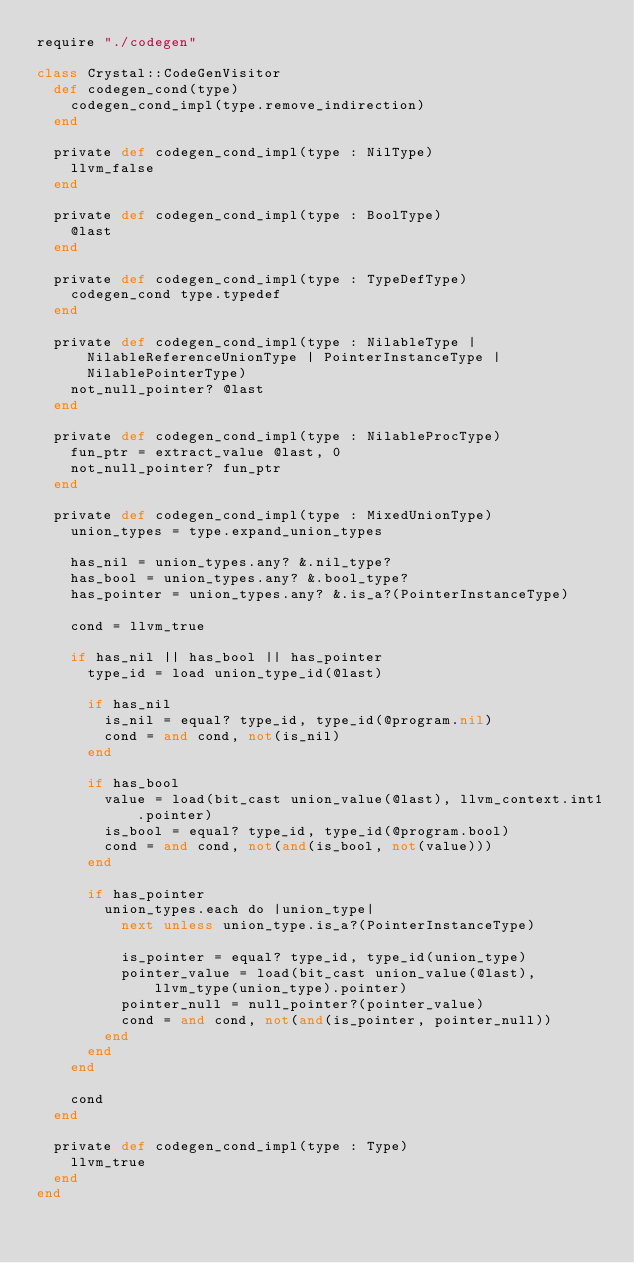<code> <loc_0><loc_0><loc_500><loc_500><_Crystal_>require "./codegen"

class Crystal::CodeGenVisitor
  def codegen_cond(type)
    codegen_cond_impl(type.remove_indirection)
  end

  private def codegen_cond_impl(type : NilType)
    llvm_false
  end

  private def codegen_cond_impl(type : BoolType)
    @last
  end

  private def codegen_cond_impl(type : TypeDefType)
    codegen_cond type.typedef
  end

  private def codegen_cond_impl(type : NilableType | NilableReferenceUnionType | PointerInstanceType | NilablePointerType)
    not_null_pointer? @last
  end

  private def codegen_cond_impl(type : NilableProcType)
    fun_ptr = extract_value @last, 0
    not_null_pointer? fun_ptr
  end

  private def codegen_cond_impl(type : MixedUnionType)
    union_types = type.expand_union_types

    has_nil = union_types.any? &.nil_type?
    has_bool = union_types.any? &.bool_type?
    has_pointer = union_types.any? &.is_a?(PointerInstanceType)

    cond = llvm_true

    if has_nil || has_bool || has_pointer
      type_id = load union_type_id(@last)

      if has_nil
        is_nil = equal? type_id, type_id(@program.nil)
        cond = and cond, not(is_nil)
      end

      if has_bool
        value = load(bit_cast union_value(@last), llvm_context.int1.pointer)
        is_bool = equal? type_id, type_id(@program.bool)
        cond = and cond, not(and(is_bool, not(value)))
      end

      if has_pointer
        union_types.each do |union_type|
          next unless union_type.is_a?(PointerInstanceType)

          is_pointer = equal? type_id, type_id(union_type)
          pointer_value = load(bit_cast union_value(@last), llvm_type(union_type).pointer)
          pointer_null = null_pointer?(pointer_value)
          cond = and cond, not(and(is_pointer, pointer_null))
        end
      end
    end

    cond
  end

  private def codegen_cond_impl(type : Type)
    llvm_true
  end
end
</code> 